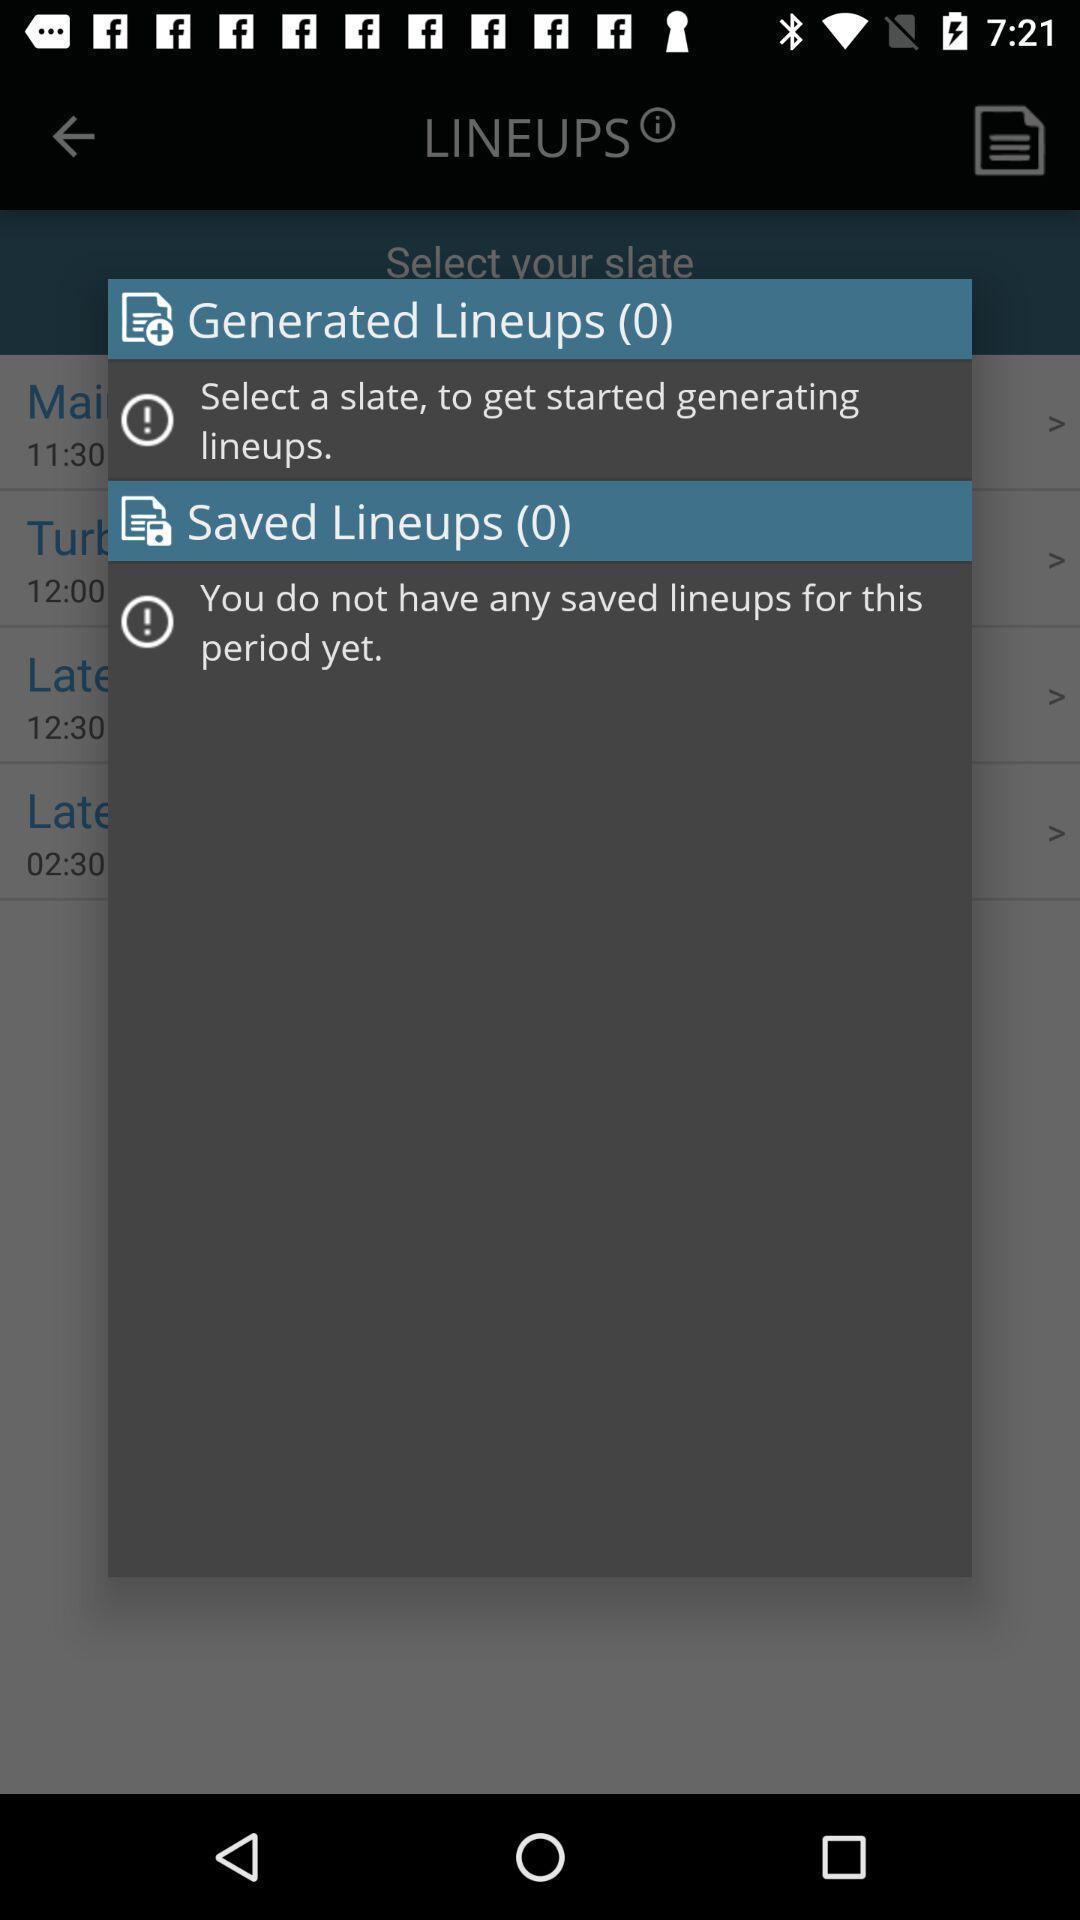Provide a detailed account of this screenshot. Pop-up showing the lineups. 